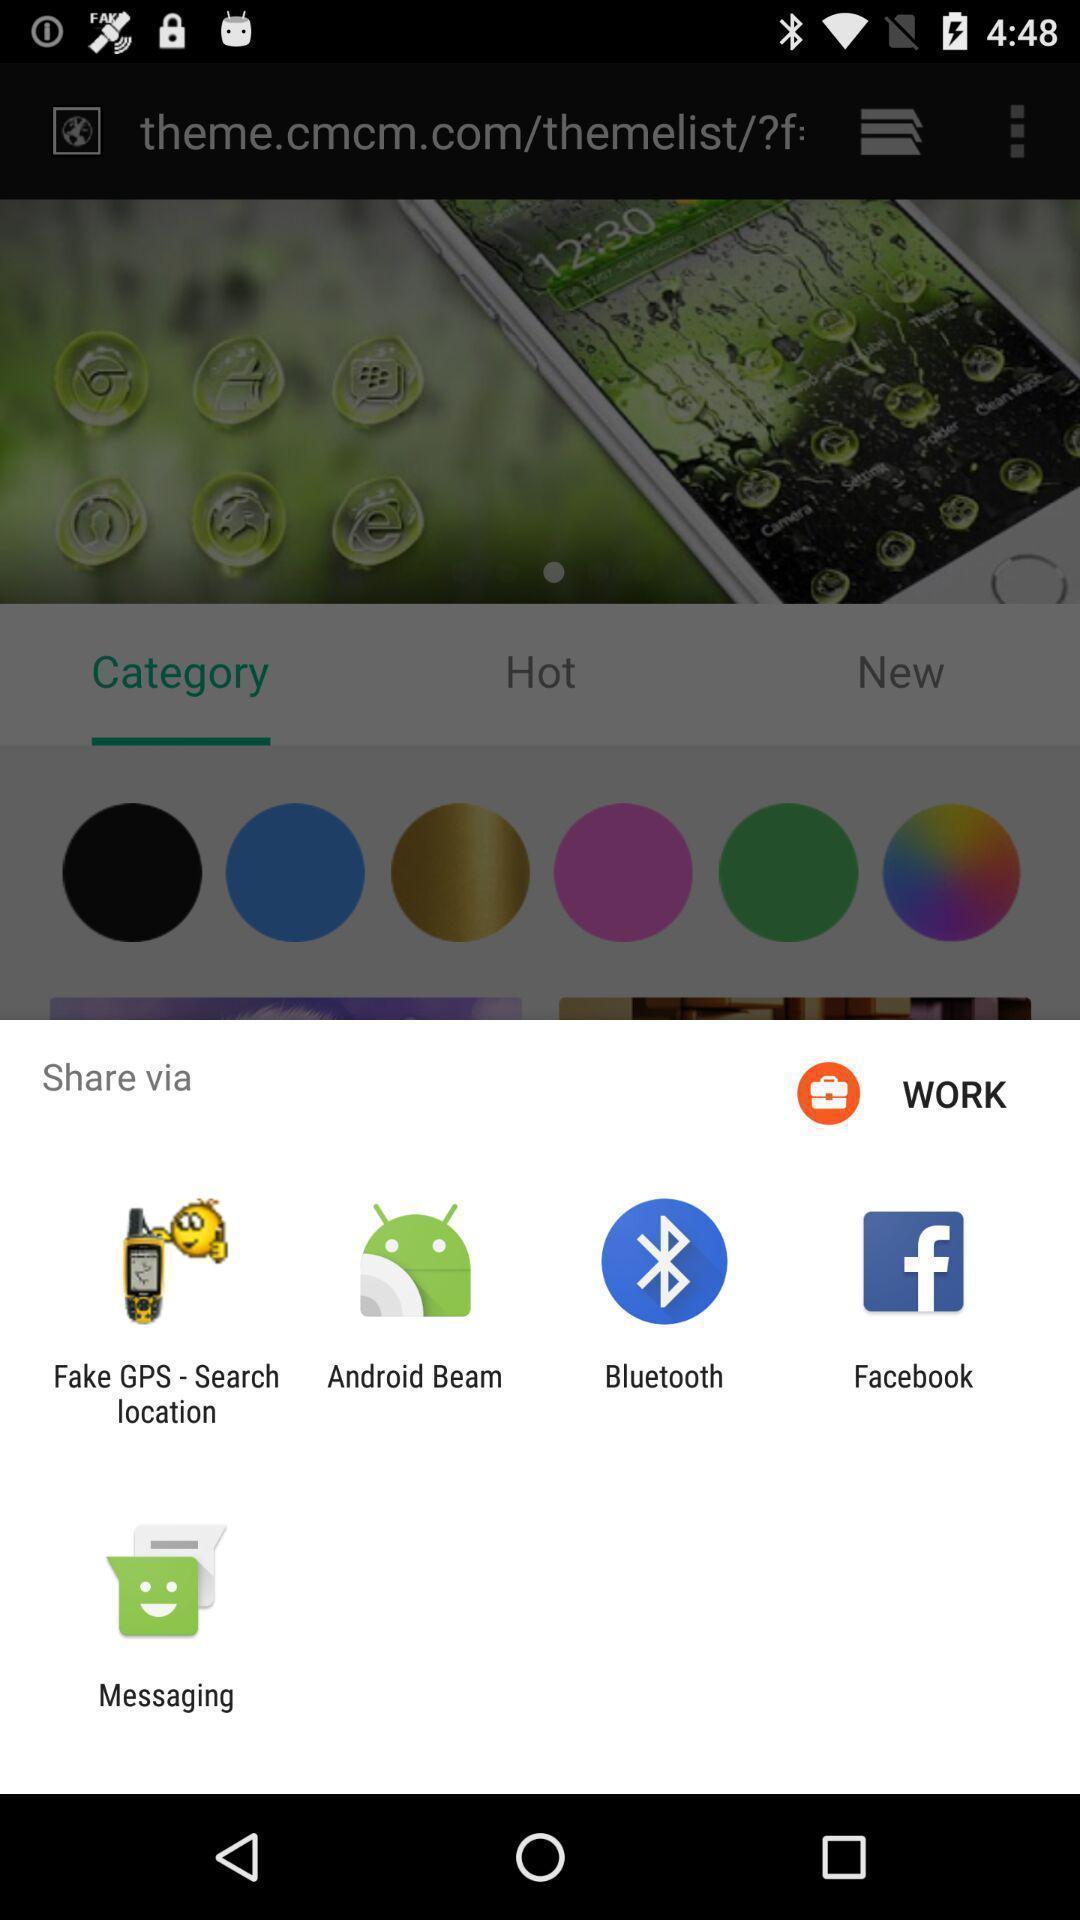Provide a textual representation of this image. Widget displaying multiple sharing applications. 